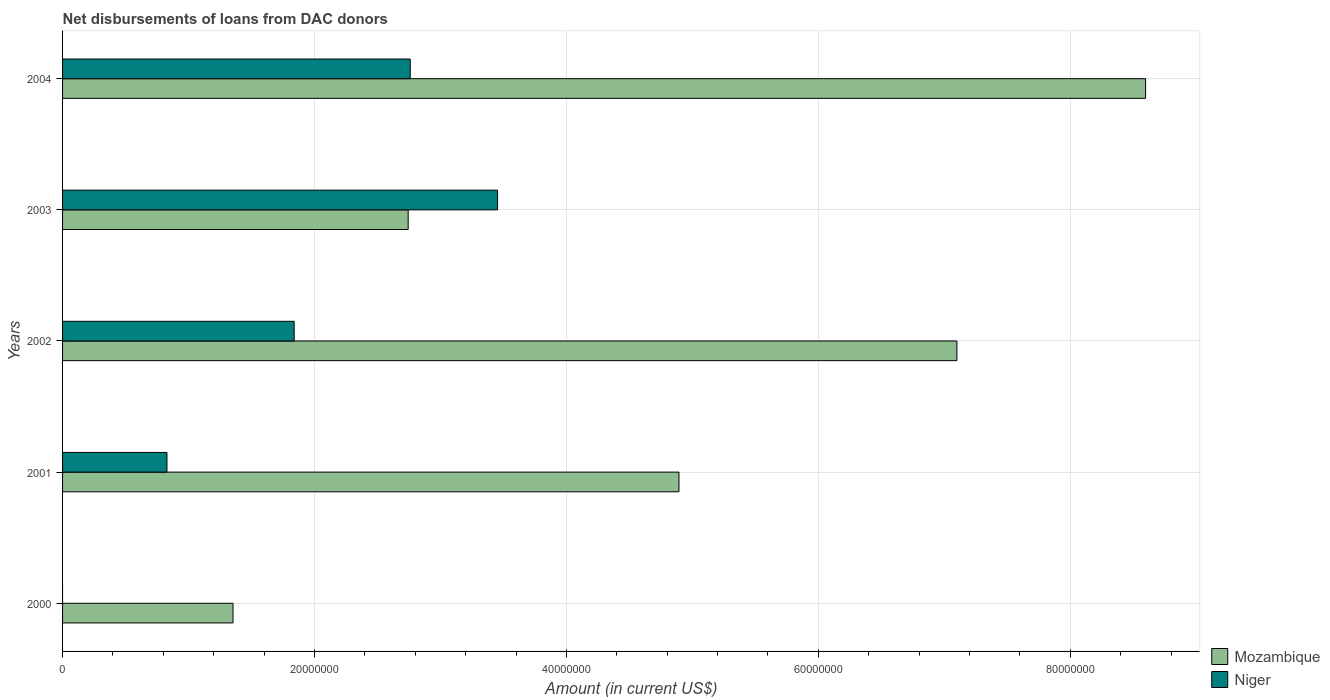Are the number of bars per tick equal to the number of legend labels?
Provide a succinct answer. No. Are the number of bars on each tick of the Y-axis equal?
Give a very brief answer. No. How many bars are there on the 2nd tick from the top?
Give a very brief answer. 2. What is the amount of loans disbursed in Niger in 2004?
Make the answer very short. 2.76e+07. Across all years, what is the maximum amount of loans disbursed in Mozambique?
Ensure brevity in your answer.  8.60e+07. Across all years, what is the minimum amount of loans disbursed in Niger?
Give a very brief answer. 0. In which year was the amount of loans disbursed in Mozambique maximum?
Make the answer very short. 2004. What is the total amount of loans disbursed in Niger in the graph?
Make the answer very short. 8.88e+07. What is the difference between the amount of loans disbursed in Niger in 2001 and that in 2004?
Give a very brief answer. -1.93e+07. What is the difference between the amount of loans disbursed in Niger in 2001 and the amount of loans disbursed in Mozambique in 2003?
Give a very brief answer. -1.91e+07. What is the average amount of loans disbursed in Mozambique per year?
Your answer should be compact. 4.94e+07. In the year 2003, what is the difference between the amount of loans disbursed in Niger and amount of loans disbursed in Mozambique?
Offer a terse response. 7.10e+06. What is the ratio of the amount of loans disbursed in Mozambique in 2003 to that in 2004?
Ensure brevity in your answer.  0.32. Is the amount of loans disbursed in Mozambique in 2001 less than that in 2004?
Offer a very short reply. Yes. What is the difference between the highest and the second highest amount of loans disbursed in Niger?
Your answer should be compact. 6.94e+06. What is the difference between the highest and the lowest amount of loans disbursed in Niger?
Your answer should be compact. 3.45e+07. Is the sum of the amount of loans disbursed in Mozambique in 2000 and 2004 greater than the maximum amount of loans disbursed in Niger across all years?
Make the answer very short. Yes. How many bars are there?
Ensure brevity in your answer.  9. Are the values on the major ticks of X-axis written in scientific E-notation?
Your response must be concise. No. Does the graph contain grids?
Your answer should be very brief. Yes. Where does the legend appear in the graph?
Make the answer very short. Bottom right. What is the title of the graph?
Your answer should be very brief. Net disbursements of loans from DAC donors. What is the label or title of the X-axis?
Keep it short and to the point. Amount (in current US$). What is the Amount (in current US$) of Mozambique in 2000?
Keep it short and to the point. 1.35e+07. What is the Amount (in current US$) in Niger in 2000?
Give a very brief answer. 0. What is the Amount (in current US$) of Mozambique in 2001?
Provide a short and direct response. 4.89e+07. What is the Amount (in current US$) in Niger in 2001?
Your answer should be compact. 8.29e+06. What is the Amount (in current US$) in Mozambique in 2002?
Provide a short and direct response. 7.10e+07. What is the Amount (in current US$) in Niger in 2002?
Provide a succinct answer. 1.84e+07. What is the Amount (in current US$) in Mozambique in 2003?
Keep it short and to the point. 2.74e+07. What is the Amount (in current US$) in Niger in 2003?
Your answer should be very brief. 3.45e+07. What is the Amount (in current US$) of Mozambique in 2004?
Your response must be concise. 8.60e+07. What is the Amount (in current US$) of Niger in 2004?
Ensure brevity in your answer.  2.76e+07. Across all years, what is the maximum Amount (in current US$) of Mozambique?
Your answer should be compact. 8.60e+07. Across all years, what is the maximum Amount (in current US$) of Niger?
Make the answer very short. 3.45e+07. Across all years, what is the minimum Amount (in current US$) of Mozambique?
Ensure brevity in your answer.  1.35e+07. Across all years, what is the minimum Amount (in current US$) in Niger?
Provide a short and direct response. 0. What is the total Amount (in current US$) in Mozambique in the graph?
Provide a short and direct response. 2.47e+08. What is the total Amount (in current US$) of Niger in the graph?
Give a very brief answer. 8.88e+07. What is the difference between the Amount (in current US$) of Mozambique in 2000 and that in 2001?
Your response must be concise. -3.54e+07. What is the difference between the Amount (in current US$) in Mozambique in 2000 and that in 2002?
Provide a succinct answer. -5.75e+07. What is the difference between the Amount (in current US$) of Mozambique in 2000 and that in 2003?
Your response must be concise. -1.39e+07. What is the difference between the Amount (in current US$) of Mozambique in 2000 and that in 2004?
Offer a very short reply. -7.24e+07. What is the difference between the Amount (in current US$) in Mozambique in 2001 and that in 2002?
Make the answer very short. -2.21e+07. What is the difference between the Amount (in current US$) in Niger in 2001 and that in 2002?
Make the answer very short. -1.01e+07. What is the difference between the Amount (in current US$) of Mozambique in 2001 and that in 2003?
Your answer should be very brief. 2.15e+07. What is the difference between the Amount (in current US$) of Niger in 2001 and that in 2003?
Give a very brief answer. -2.62e+07. What is the difference between the Amount (in current US$) in Mozambique in 2001 and that in 2004?
Ensure brevity in your answer.  -3.70e+07. What is the difference between the Amount (in current US$) of Niger in 2001 and that in 2004?
Offer a very short reply. -1.93e+07. What is the difference between the Amount (in current US$) of Mozambique in 2002 and that in 2003?
Ensure brevity in your answer.  4.36e+07. What is the difference between the Amount (in current US$) in Niger in 2002 and that in 2003?
Your answer should be compact. -1.61e+07. What is the difference between the Amount (in current US$) in Mozambique in 2002 and that in 2004?
Your response must be concise. -1.50e+07. What is the difference between the Amount (in current US$) of Niger in 2002 and that in 2004?
Provide a succinct answer. -9.21e+06. What is the difference between the Amount (in current US$) in Mozambique in 2003 and that in 2004?
Offer a terse response. -5.85e+07. What is the difference between the Amount (in current US$) of Niger in 2003 and that in 2004?
Offer a terse response. 6.94e+06. What is the difference between the Amount (in current US$) of Mozambique in 2000 and the Amount (in current US$) of Niger in 2001?
Keep it short and to the point. 5.24e+06. What is the difference between the Amount (in current US$) of Mozambique in 2000 and the Amount (in current US$) of Niger in 2002?
Ensure brevity in your answer.  -4.86e+06. What is the difference between the Amount (in current US$) in Mozambique in 2000 and the Amount (in current US$) in Niger in 2003?
Offer a very short reply. -2.10e+07. What is the difference between the Amount (in current US$) of Mozambique in 2000 and the Amount (in current US$) of Niger in 2004?
Your answer should be very brief. -1.41e+07. What is the difference between the Amount (in current US$) of Mozambique in 2001 and the Amount (in current US$) of Niger in 2002?
Your response must be concise. 3.05e+07. What is the difference between the Amount (in current US$) in Mozambique in 2001 and the Amount (in current US$) in Niger in 2003?
Offer a terse response. 1.44e+07. What is the difference between the Amount (in current US$) of Mozambique in 2001 and the Amount (in current US$) of Niger in 2004?
Offer a very short reply. 2.13e+07. What is the difference between the Amount (in current US$) of Mozambique in 2002 and the Amount (in current US$) of Niger in 2003?
Offer a very short reply. 3.65e+07. What is the difference between the Amount (in current US$) of Mozambique in 2002 and the Amount (in current US$) of Niger in 2004?
Make the answer very short. 4.34e+07. What is the difference between the Amount (in current US$) of Mozambique in 2003 and the Amount (in current US$) of Niger in 2004?
Ensure brevity in your answer.  -1.62e+05. What is the average Amount (in current US$) in Mozambique per year?
Give a very brief answer. 4.94e+07. What is the average Amount (in current US$) in Niger per year?
Your response must be concise. 1.78e+07. In the year 2001, what is the difference between the Amount (in current US$) of Mozambique and Amount (in current US$) of Niger?
Make the answer very short. 4.06e+07. In the year 2002, what is the difference between the Amount (in current US$) in Mozambique and Amount (in current US$) in Niger?
Provide a short and direct response. 5.26e+07. In the year 2003, what is the difference between the Amount (in current US$) of Mozambique and Amount (in current US$) of Niger?
Provide a short and direct response. -7.10e+06. In the year 2004, what is the difference between the Amount (in current US$) in Mozambique and Amount (in current US$) in Niger?
Offer a very short reply. 5.84e+07. What is the ratio of the Amount (in current US$) in Mozambique in 2000 to that in 2001?
Ensure brevity in your answer.  0.28. What is the ratio of the Amount (in current US$) in Mozambique in 2000 to that in 2002?
Keep it short and to the point. 0.19. What is the ratio of the Amount (in current US$) in Mozambique in 2000 to that in 2003?
Give a very brief answer. 0.49. What is the ratio of the Amount (in current US$) in Mozambique in 2000 to that in 2004?
Offer a very short reply. 0.16. What is the ratio of the Amount (in current US$) of Mozambique in 2001 to that in 2002?
Make the answer very short. 0.69. What is the ratio of the Amount (in current US$) in Niger in 2001 to that in 2002?
Offer a terse response. 0.45. What is the ratio of the Amount (in current US$) in Mozambique in 2001 to that in 2003?
Give a very brief answer. 1.78. What is the ratio of the Amount (in current US$) in Niger in 2001 to that in 2003?
Provide a short and direct response. 0.24. What is the ratio of the Amount (in current US$) of Mozambique in 2001 to that in 2004?
Make the answer very short. 0.57. What is the ratio of the Amount (in current US$) of Niger in 2001 to that in 2004?
Make the answer very short. 0.3. What is the ratio of the Amount (in current US$) of Mozambique in 2002 to that in 2003?
Offer a very short reply. 2.59. What is the ratio of the Amount (in current US$) of Niger in 2002 to that in 2003?
Provide a short and direct response. 0.53. What is the ratio of the Amount (in current US$) in Mozambique in 2002 to that in 2004?
Offer a terse response. 0.83. What is the ratio of the Amount (in current US$) of Niger in 2002 to that in 2004?
Offer a very short reply. 0.67. What is the ratio of the Amount (in current US$) in Mozambique in 2003 to that in 2004?
Offer a very short reply. 0.32. What is the ratio of the Amount (in current US$) in Niger in 2003 to that in 2004?
Ensure brevity in your answer.  1.25. What is the difference between the highest and the second highest Amount (in current US$) in Mozambique?
Keep it short and to the point. 1.50e+07. What is the difference between the highest and the second highest Amount (in current US$) in Niger?
Keep it short and to the point. 6.94e+06. What is the difference between the highest and the lowest Amount (in current US$) in Mozambique?
Your response must be concise. 7.24e+07. What is the difference between the highest and the lowest Amount (in current US$) of Niger?
Provide a short and direct response. 3.45e+07. 